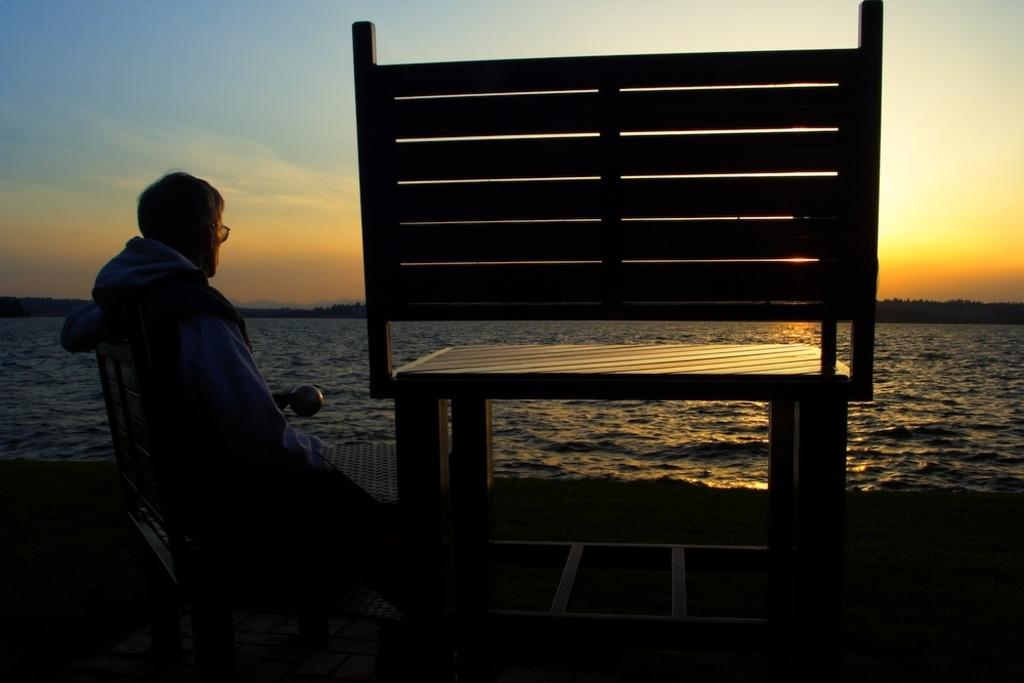What is located in the center of the image? There is a bench in the center of the image. Who is sitting on the bench? There is a person sitting on the bench. Can you describe the person's appearance? The person is wearing a coat and glasses. What can be seen in the background of the image? There is water and a sunset visible in the background. What language is the person speaking on the bench? There is no indication in the image that the person is speaking any language. 